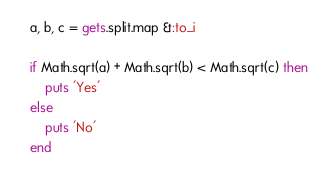Convert code to text. <code><loc_0><loc_0><loc_500><loc_500><_Ruby_>a, b, c = gets.split.map &:to_i

if Math.sqrt(a) + Math.sqrt(b) < Math.sqrt(c) then
	puts 'Yes'
else
	puts 'No'
end</code> 